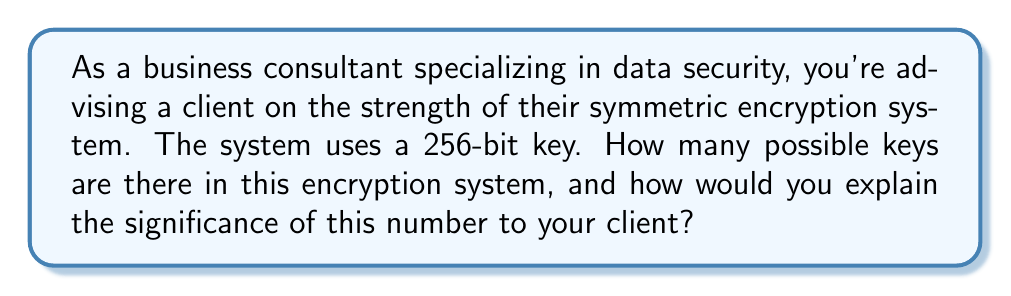Help me with this question. To determine the number of possible keys in a 256-bit symmetric encryption system, we need to follow these steps:

1. Understand the concept of bits:
   Each bit can have two possible values: 0 or 1.

2. Calculate the number of possible combinations:
   For a 256-bit key, we have 2 choices for each of the 256 positions.
   This can be expressed as $2^{256}$.

3. Compute the result:
   $2^{256} = 115,792,089,237,316,195,423,570,985,008,687,907,853,269,984,665,640,564,039,457,584,007,913,129,639,936$

4. Interpret the result:
   This number is astronomically large, which is crucial for the security of the encryption system.

5. Explain the significance to the client:
   - The large number of possible keys makes brute-force attacks infeasible.
   - Even with a supercomputer capable of trying 1 trillion keys per second, it would take longer than the age of the universe to try all possible keys.
   - This level of security is suitable for protecting highly sensitive business data.

Mathematically, we can express the probability of guessing the correct key on the first try as:

$$P(\text{correct guess}) = \frac{1}{2^{256}}$$

This probability is infinitesimally small, highlighting the strength of the encryption system.
Answer: $2^{256}$ possible keys 